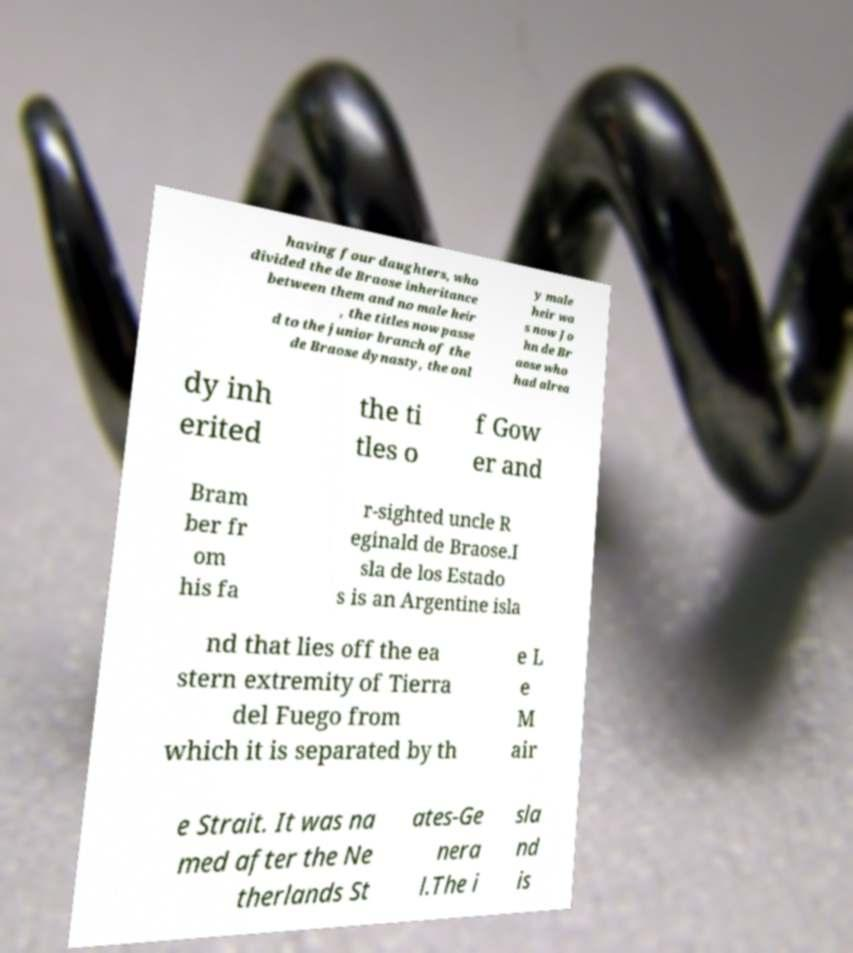I need the written content from this picture converted into text. Can you do that? having four daughters, who divided the de Braose inheritance between them and no male heir , the titles now passe d to the junior branch of the de Braose dynasty, the onl y male heir wa s now Jo hn de Br aose who had alrea dy inh erited the ti tles o f Gow er and Bram ber fr om his fa r-sighted uncle R eginald de Braose.I sla de los Estado s is an Argentine isla nd that lies off the ea stern extremity of Tierra del Fuego from which it is separated by th e L e M air e Strait. It was na med after the Ne therlands St ates-Ge nera l.The i sla nd is 